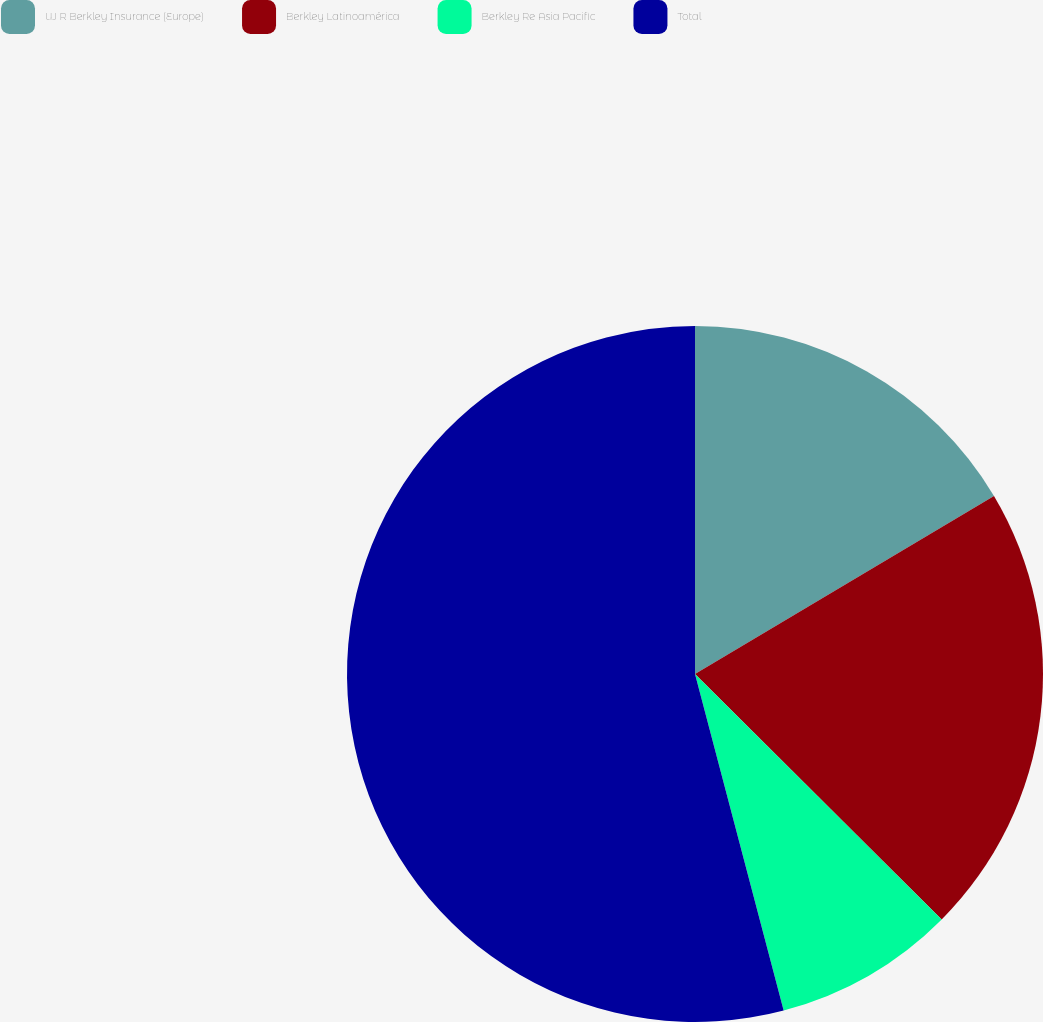Convert chart. <chart><loc_0><loc_0><loc_500><loc_500><pie_chart><fcel>W R Berkley Insurance (Europe)<fcel>Berkley Latinoamérica<fcel>Berkley Re Asia Pacific<fcel>Total<nl><fcel>16.45%<fcel>21.01%<fcel>8.44%<fcel>54.1%<nl></chart> 